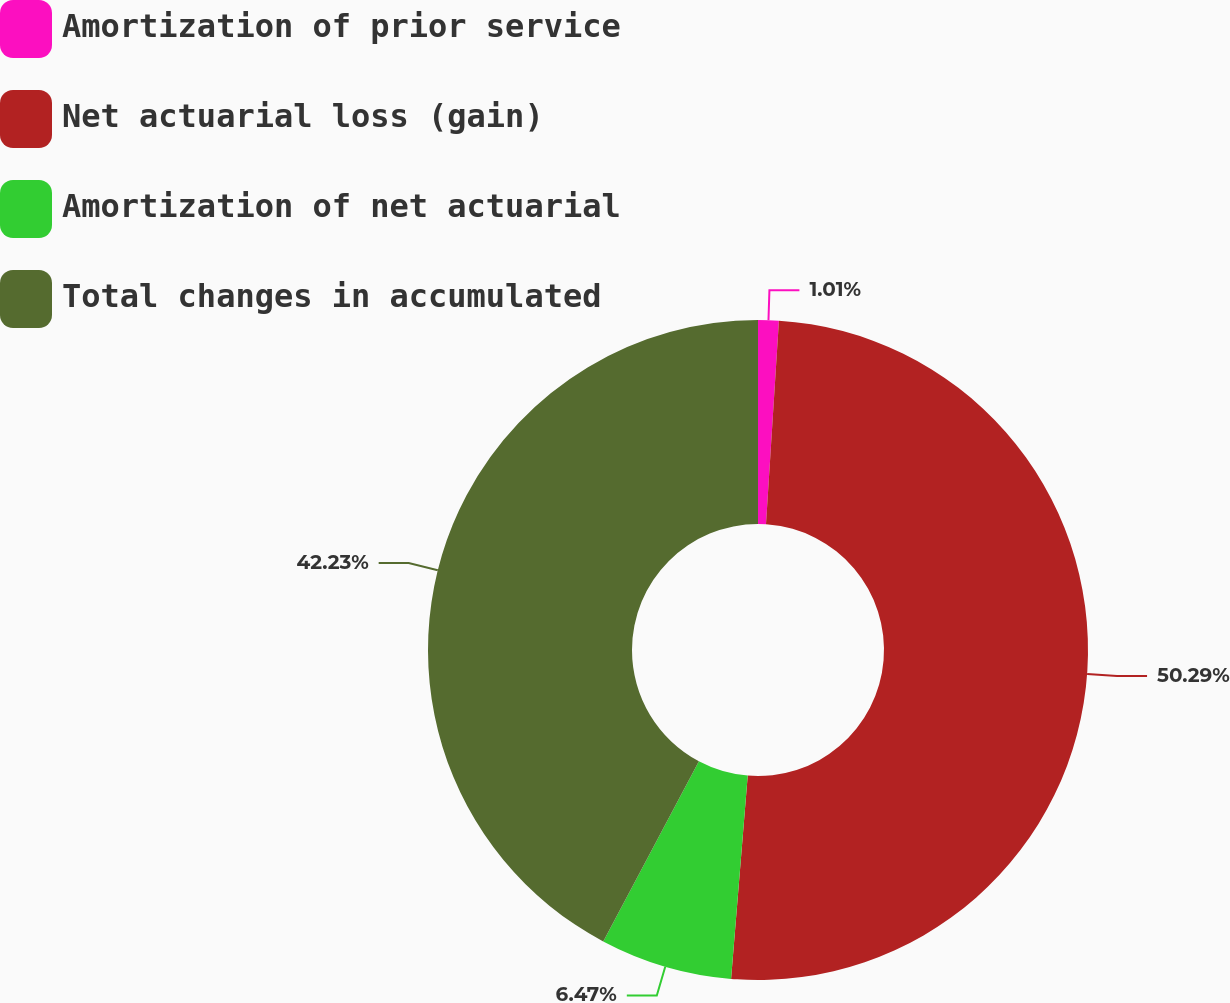<chart> <loc_0><loc_0><loc_500><loc_500><pie_chart><fcel>Amortization of prior service<fcel>Net actuarial loss (gain)<fcel>Amortization of net actuarial<fcel>Total changes in accumulated<nl><fcel>1.01%<fcel>50.29%<fcel>6.47%<fcel>42.23%<nl></chart> 